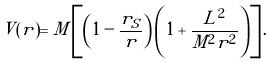<formula> <loc_0><loc_0><loc_500><loc_500>V ( r ) = M \left [ \left ( 1 - \frac { r _ { S } } { r } \right ) \left ( 1 + \frac { L ^ { 2 } } { M ^ { 2 } r ^ { 2 } } \right ) \right ] .</formula> 